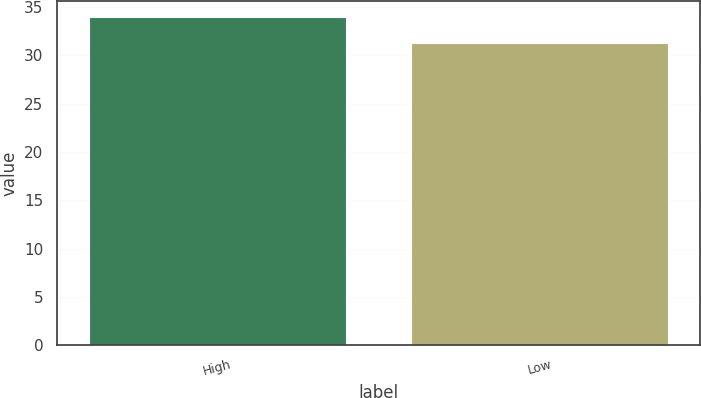Convert chart. <chart><loc_0><loc_0><loc_500><loc_500><bar_chart><fcel>High<fcel>Low<nl><fcel>33.92<fcel>31.27<nl></chart> 